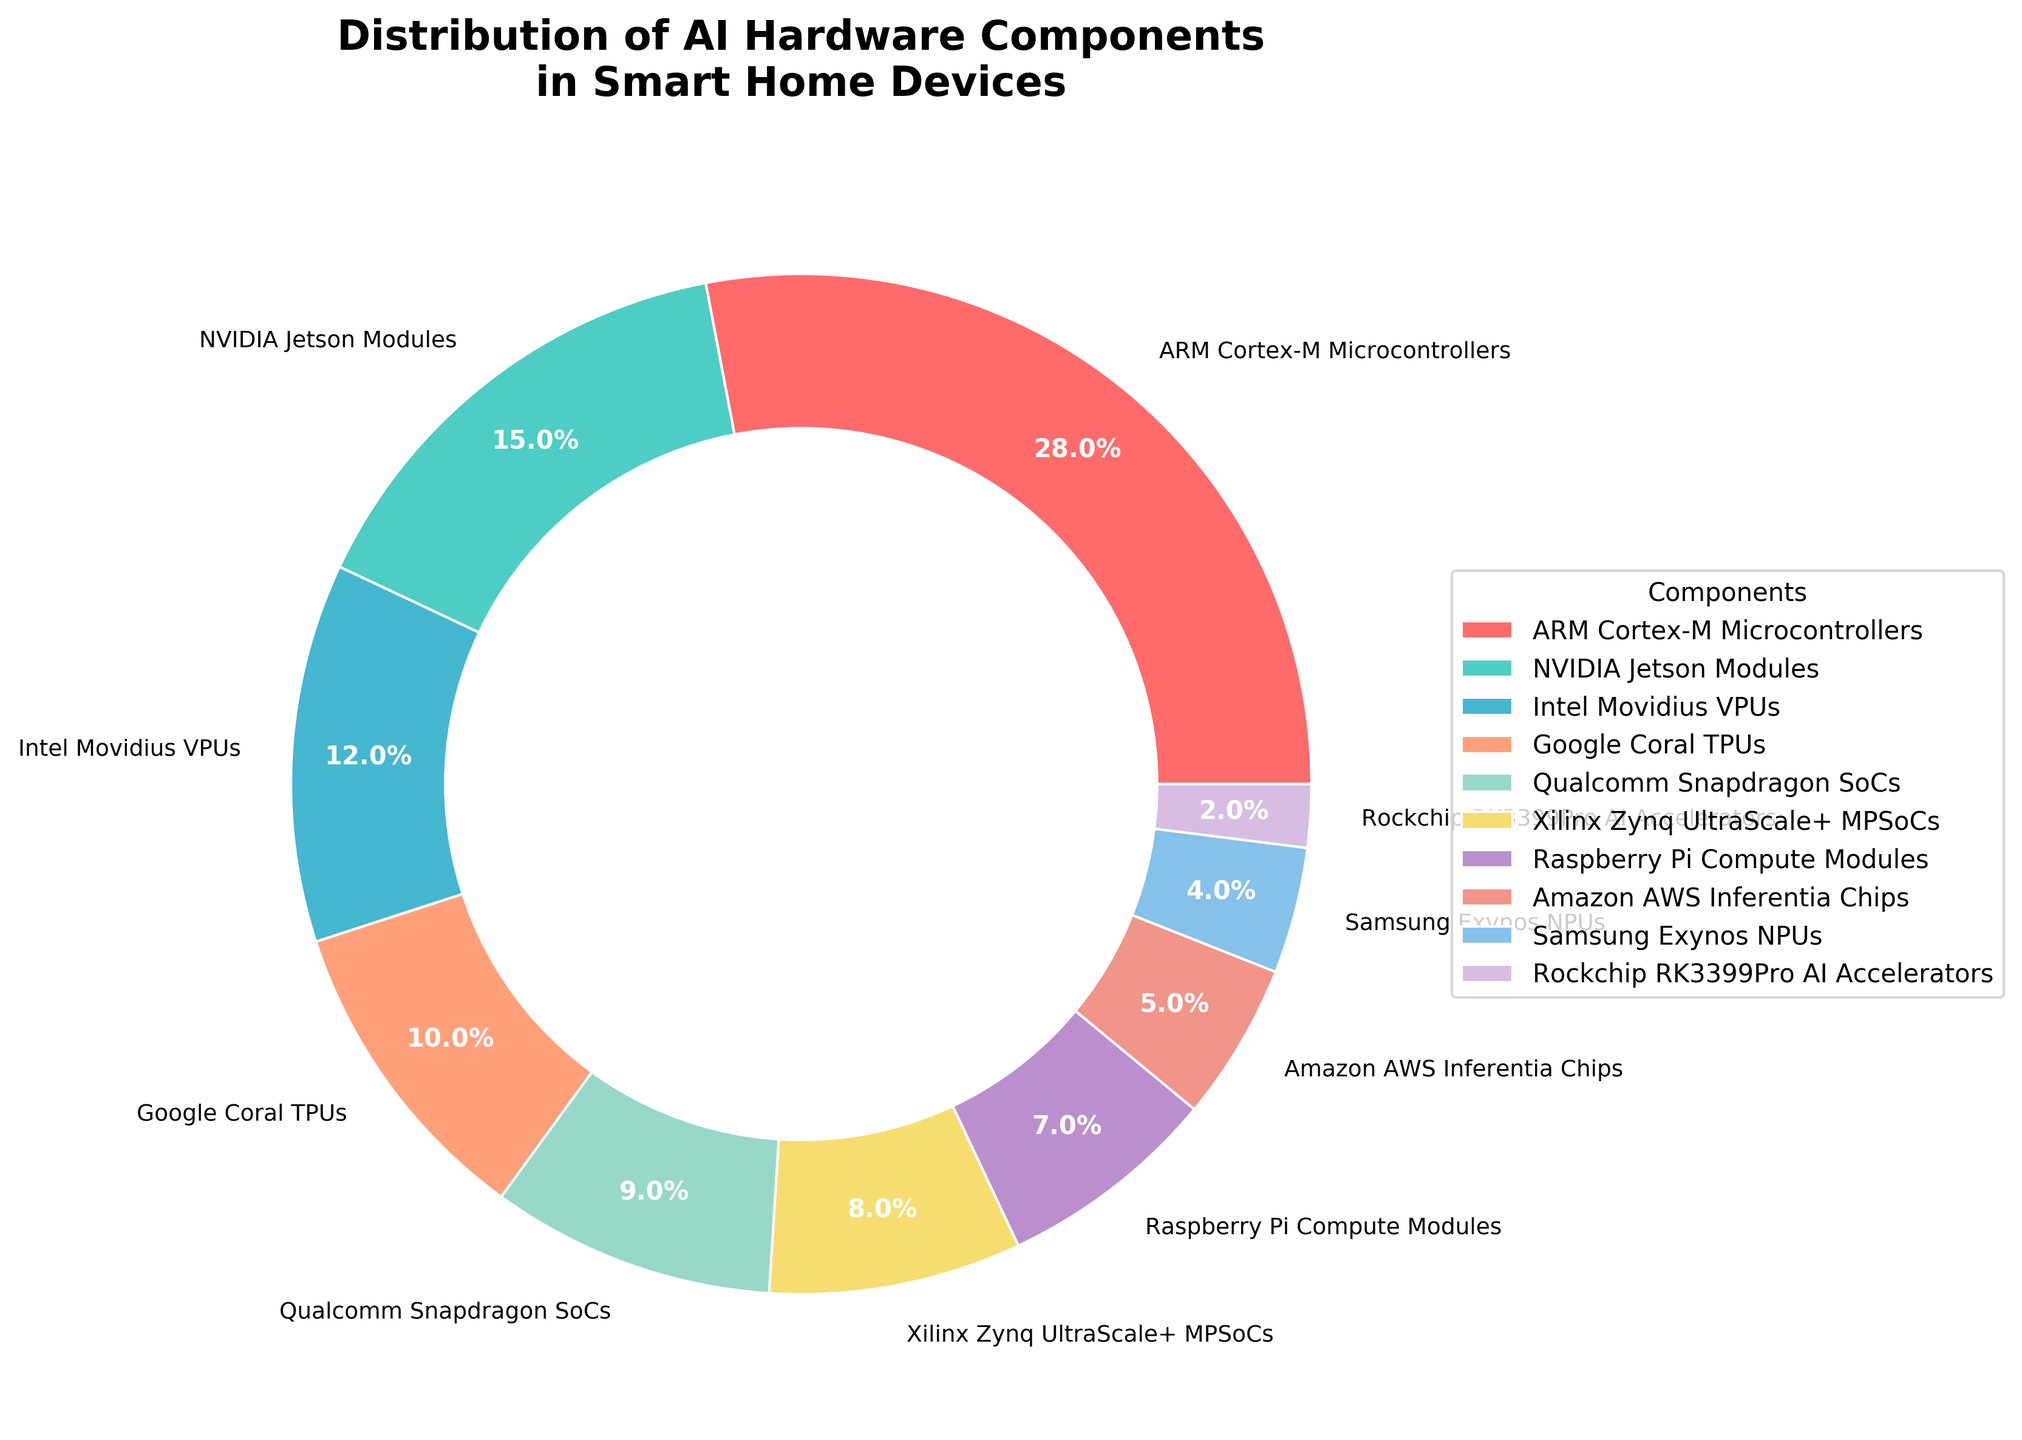What's the total percentage of components contributed by ARM Cortex-M Microcontrollers, NVIDIA Jetson Modules, and Intel Movidius VPUs? Add the percentages of ARM Cortex-M Microcontrollers (28%), NVIDIA Jetson Modules (15%), and Intel Movidius VPUs (12%) together: 28 + 15 + 12 = 55
Answer: 55% Which component has the lowest percentage contribution? By examining the pie chart, the segment with the smallest slice represents the Rockchip RK3399Pro AI Accelerators.
Answer: Rockchip RK3399Pro AI Accelerators How do the combined contributions of Google Coral TPUs and Qualcomm Snapdragon SoCs compare to those of Xilinx Zynq UltraScale+ MPSoCs and Raspberry Pi Compute Modules? Sum the percentages of Google Coral TPUs (10%) and Qualcomm Snapdragon SoCs (9%) which equals 19%, and compare it to the sum of Xilinx Zynq UltraScale+ MPSoCs (8%) and Raspberry Pi Compute Modules (7%) which equals 15%: 19% is greater than 15%.
Answer: Google Coral TPUs and Qualcomm Snapdragon SoCs contribute more What is the difference in percentage between the highest and lowest contributing components? Subtract the percentage of Rockchip RK3399Pro AI Accelerators (2%) from that of ARM Cortex-M Microcontrollers (28%): 28 - 2 = 26
Answer: 26% Which components together make up more than half of the total percentage? Sum the percentages until the total surpasses 50%. ARM Cortex-M Microcontrollers (28%), NVIDIA Jetson Modules (15%), and Intel Movidius VPUs (12%) together make 55%.
Answer: ARM Cortex-M Microcontrollers, NVIDIA Jetson Modules, and Intel Movidius VPUs What is the ratio of the contribution of Amazon AWS Inferentia Chips to the contribution of Samsung Exynos NPUs? Ratio of Amazon AWS Inferentia Chips (5%) to Samsung Exynos NPUs (4%) is calculated as 5:4.
Answer: 5:4 Between Qualcomm Snapdragon SoCs and Raspberry Pi Compute Modules, which one has a higher percentage contribution and by how much? Qualcomm Snapdragon SoCs contribute 9% while Raspberry Pi Compute Modules contribute 7%. The difference is 9 - 7 = 2%.
Answer: Qualcomm Snapdragon SoCs by 2% How many components contribute less than 10% individually? Visual inspection shows Google Coral TPUs (10%), Qualcomm Snapdragon SoCs (9%), Xilinx Zynq UltraScale+ MPSoCs (8%), Raspberry Pi Compute Modules (7%), Amazon AWS Inferentia Chips (5%), Samsung Exynos NPUs (4%), Rockchip RK3399Pro AI Accelerators (2%), making a total of 7 components.
Answer: 7 components Which component uses the lightest shade of color in the chart? Visual assessment identifies the segment with the lightest shade of color as representing Samsung Exynos NPUs.
Answer: Samsung Exynos NPUs What percentage more does the top contributing component have compared to the second top component? Subtract the second highest percentage, NVIDIA Jetson Modules (15%), from the highest, ARM Cortex-M Microcontrollers (28%): 28 - 15 = 13%.
Answer: 13% 